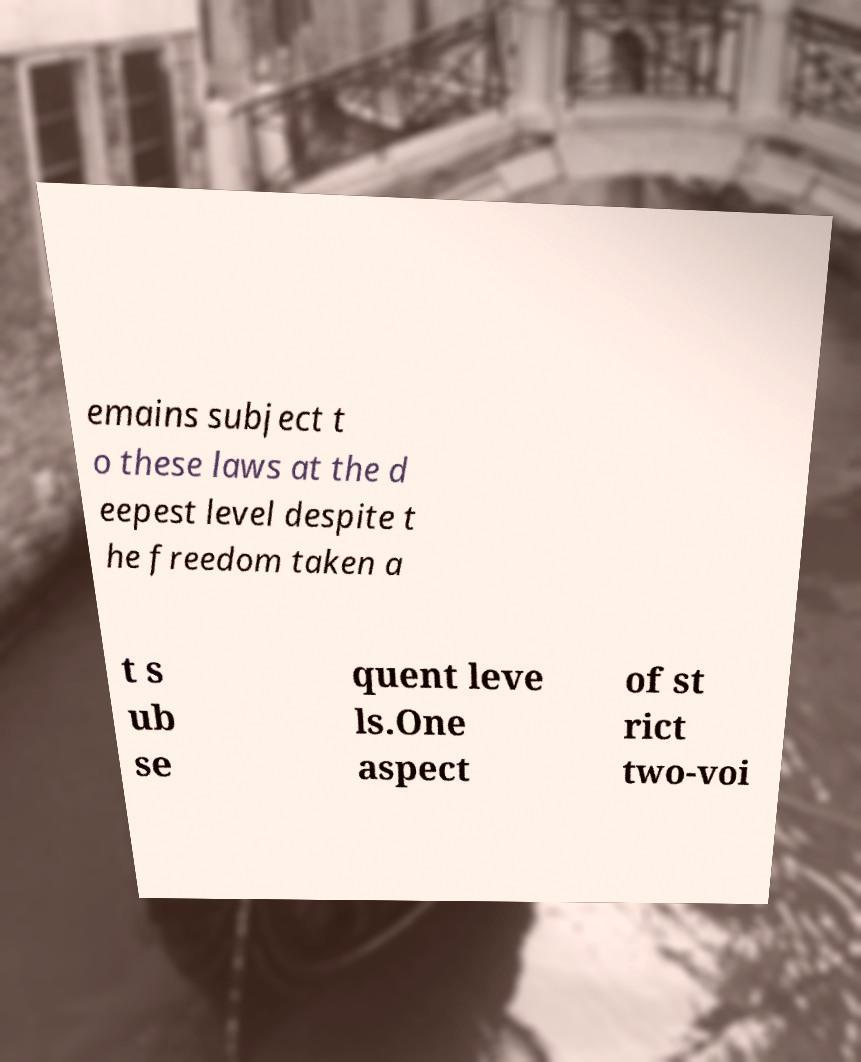For documentation purposes, I need the text within this image transcribed. Could you provide that? emains subject t o these laws at the d eepest level despite t he freedom taken a t s ub se quent leve ls.One aspect of st rict two-voi 